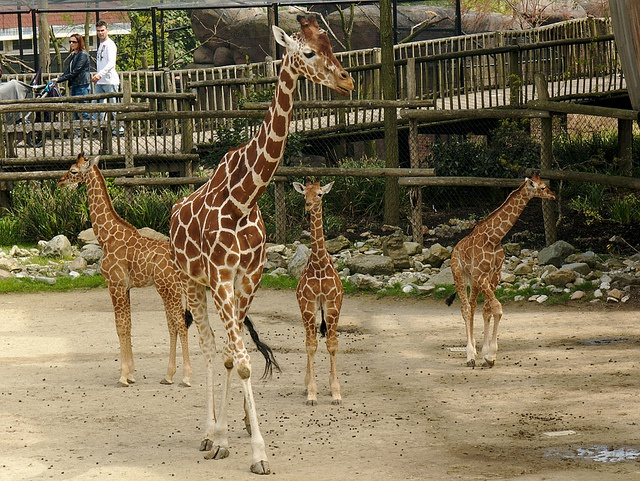Describe the objects in this image and their specific colors. I can see giraffe in gray, maroon, and tan tones, giraffe in gray, olive, tan, and maroon tones, giraffe in gray, maroon, tan, and olive tones, giraffe in gray, tan, maroon, and olive tones, and people in gray, black, olive, and darkblue tones in this image. 